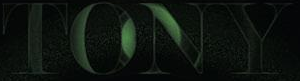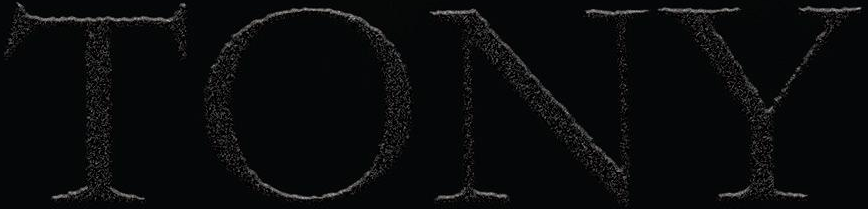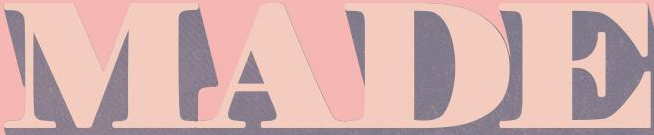What text is displayed in these images sequentially, separated by a semicolon? TONY; TONY; MADE 